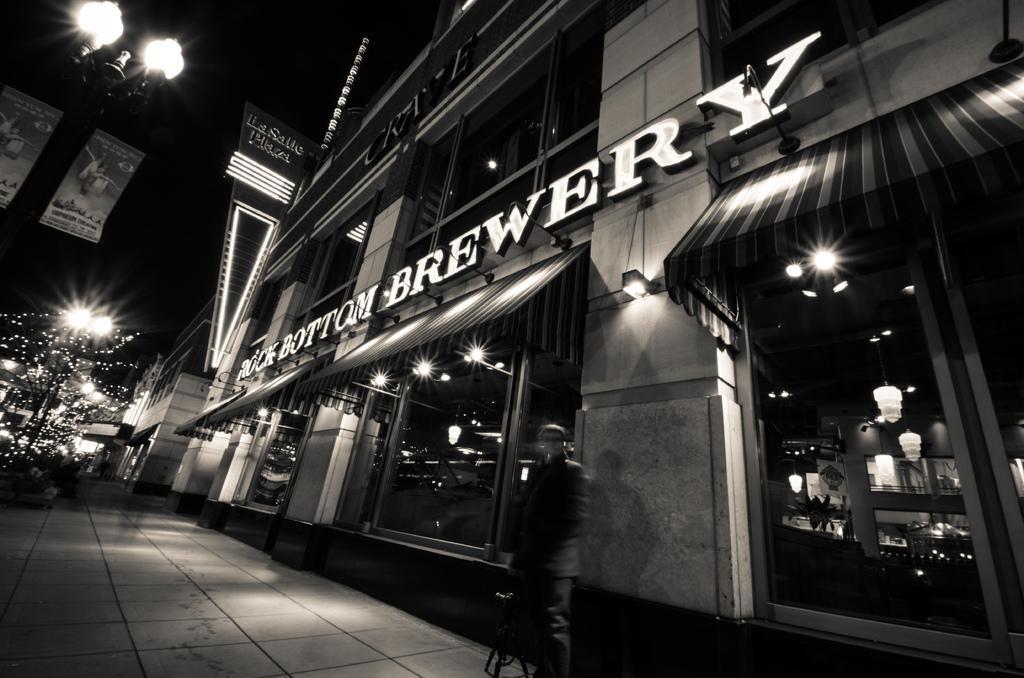In one or two sentences, can you explain what this image depicts? On the left side, there are lights attached to the poles and there is a footpath. On the right side, there is a building having a hoarding on the wall and windows. Beside this building, there is a person standing on the footpath. In the background, there are lights arranged and there are buildings. And the background is dark in color. 